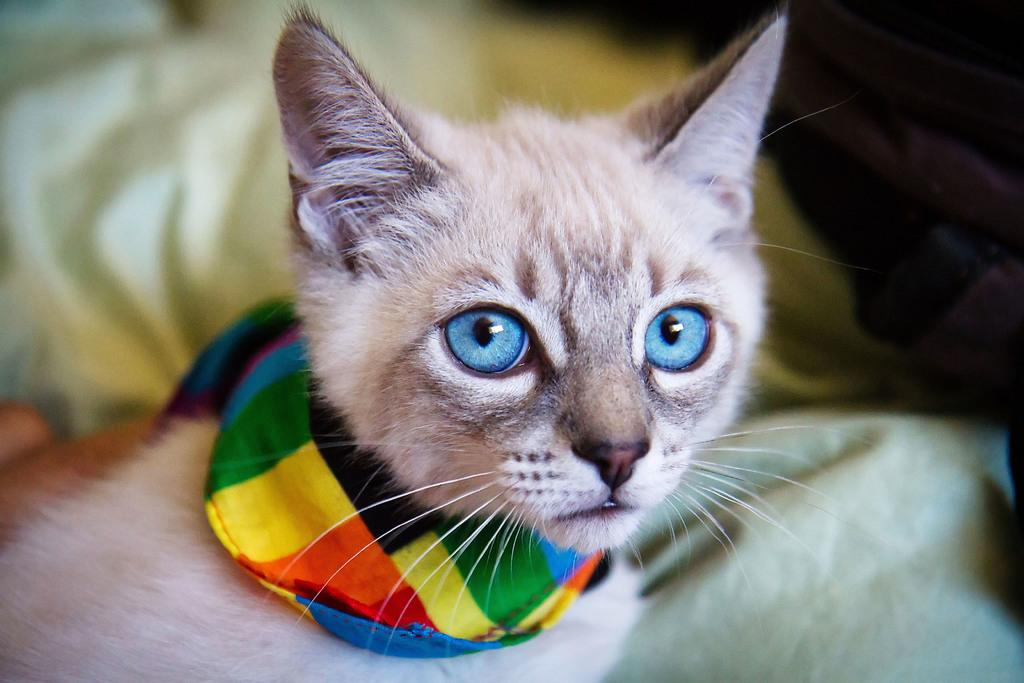What type of animal is present in the image? There is a cat in the image. How is the cat dressed in the image? The cat is wearing a colorful kerchief around its neck. What can be seen on the surface in the image? There are objects on the surface in the image. What country is depicted in the background of the image? There is no country depicted in the background of the image; it only features a cat wearing a kerchief and objects on a surface. 